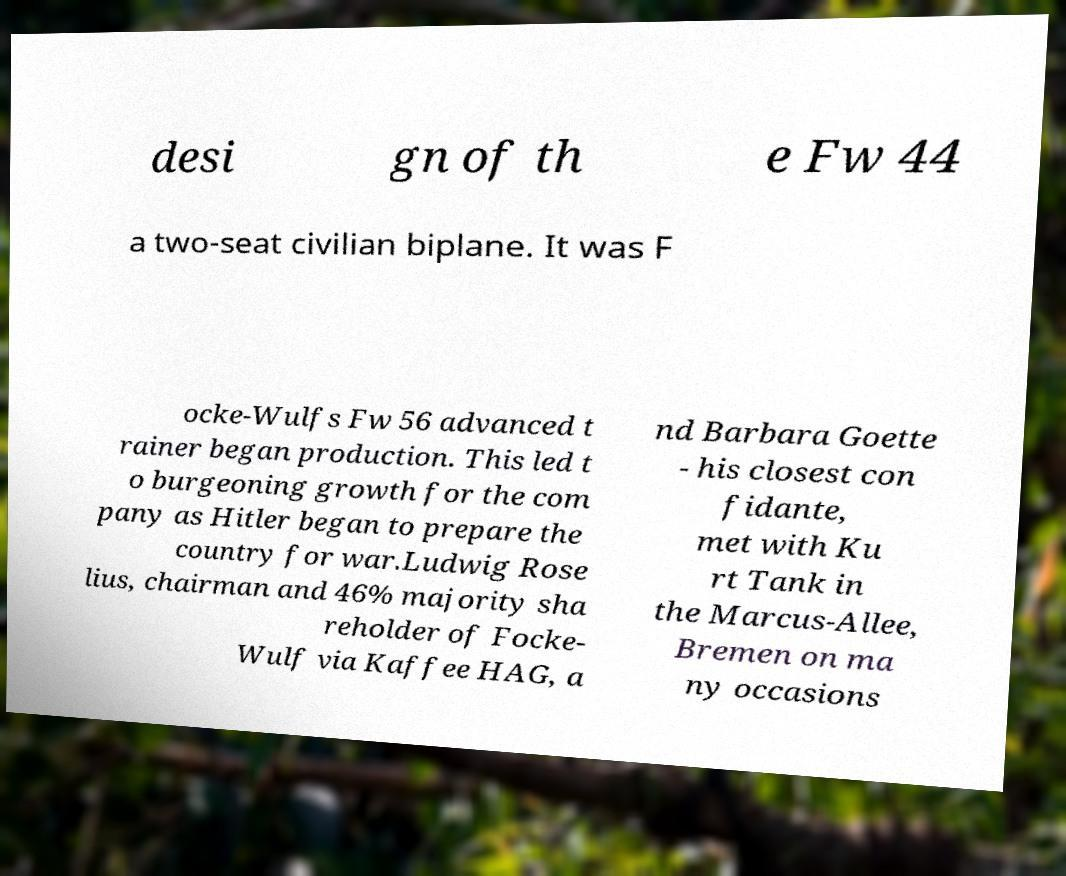For documentation purposes, I need the text within this image transcribed. Could you provide that? desi gn of th e Fw 44 a two-seat civilian biplane. It was F ocke-Wulfs Fw 56 advanced t rainer began production. This led t o burgeoning growth for the com pany as Hitler began to prepare the country for war.Ludwig Rose lius, chairman and 46% majority sha reholder of Focke- Wulf via Kaffee HAG, a nd Barbara Goette - his closest con fidante, met with Ku rt Tank in the Marcus-Allee, Bremen on ma ny occasions 